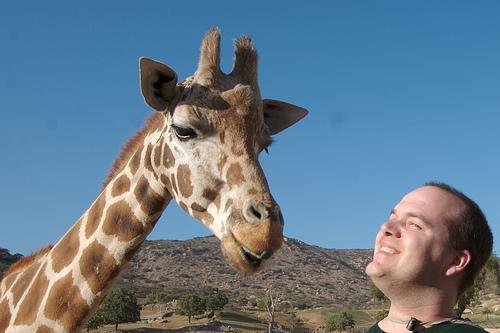How many people are in the picture?
Give a very brief answer. 1. 